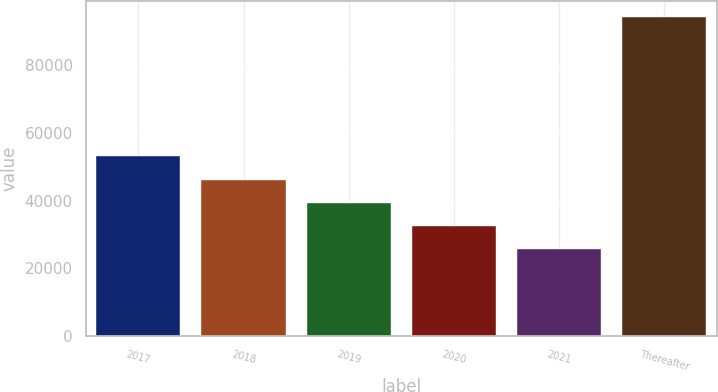Convert chart. <chart><loc_0><loc_0><loc_500><loc_500><bar_chart><fcel>2017<fcel>2018<fcel>2019<fcel>2020<fcel>2021<fcel>Thereafter<nl><fcel>53021.6<fcel>46183.7<fcel>39345.8<fcel>32507.9<fcel>25670<fcel>94049<nl></chart> 